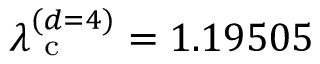Convert formula to latex. <formula><loc_0><loc_0><loc_500><loc_500>\lambda _ { c } ^ { ( d = 4 ) } = 1 . 1 9 5 0 5</formula> 